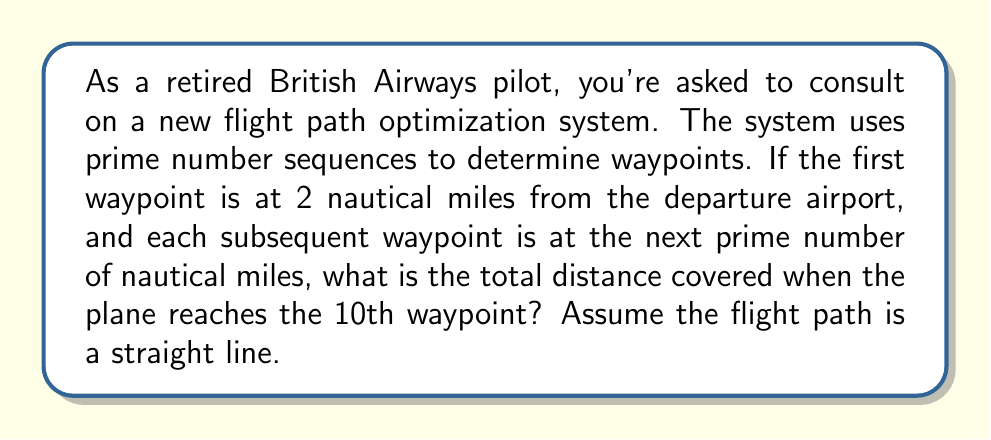Can you solve this math problem? To solve this problem, we need to follow these steps:

1. Identify the first 10 prime numbers:
   The first 10 prime numbers are 2, 3, 5, 7, 11, 13, 17, 19, 23, and 29.

2. Calculate the distances of each waypoint from the departure airport:
   - Waypoint 1: 2 nautical miles
   - Waypoint 2: 3 nautical miles
   - Waypoint 3: 5 nautical miles
   - Waypoint 4: 7 nautical miles
   - Waypoint 5: 11 nautical miles
   - Waypoint 6: 13 nautical miles
   - Waypoint 7: 17 nautical miles
   - Waypoint 8: 19 nautical miles
   - Waypoint 9: 23 nautical miles
   - Waypoint 10: 29 nautical miles

3. The total distance covered is the distance to the 10th waypoint, which is 29 nautical miles.

This problem utilizes the pilot's understanding of waypoints and distance measurements in nautical miles, while incorporating the mathematical concept of prime number sequences.
Answer: The total distance covered when the plane reaches the 10th waypoint is 29 nautical miles. 